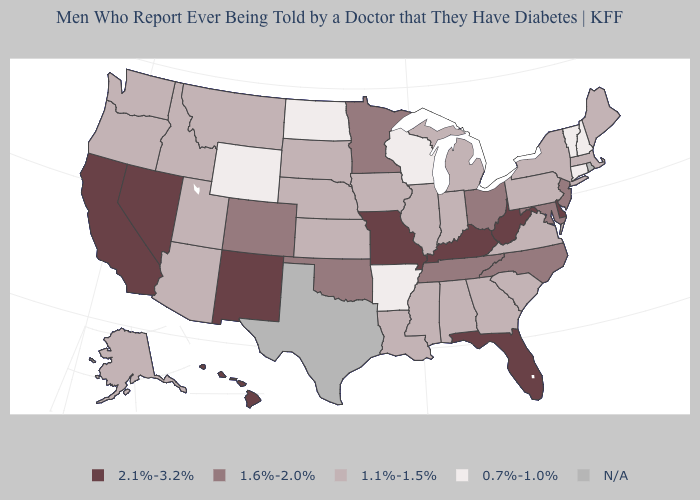What is the value of North Carolina?
Give a very brief answer. 1.6%-2.0%. Which states have the highest value in the USA?
Short answer required. California, Delaware, Florida, Hawaii, Kentucky, Missouri, Nevada, New Mexico, West Virginia. Name the states that have a value in the range 1.6%-2.0%?
Concise answer only. Colorado, Maryland, Minnesota, New Jersey, North Carolina, Ohio, Oklahoma, Tennessee. Name the states that have a value in the range 2.1%-3.2%?
Be succinct. California, Delaware, Florida, Hawaii, Kentucky, Missouri, Nevada, New Mexico, West Virginia. Which states have the highest value in the USA?
Give a very brief answer. California, Delaware, Florida, Hawaii, Kentucky, Missouri, Nevada, New Mexico, West Virginia. What is the value of Tennessee?
Keep it brief. 1.6%-2.0%. Does the first symbol in the legend represent the smallest category?
Short answer required. No. What is the highest value in states that border Idaho?
Be succinct. 2.1%-3.2%. What is the value of Delaware?
Concise answer only. 2.1%-3.2%. What is the highest value in the USA?
Be succinct. 2.1%-3.2%. What is the value of North Dakota?
Answer briefly. 0.7%-1.0%. What is the lowest value in states that border Vermont?
Short answer required. 0.7%-1.0%. What is the value of Pennsylvania?
Quick response, please. 1.1%-1.5%. What is the value of New Hampshire?
Write a very short answer. 0.7%-1.0%. 